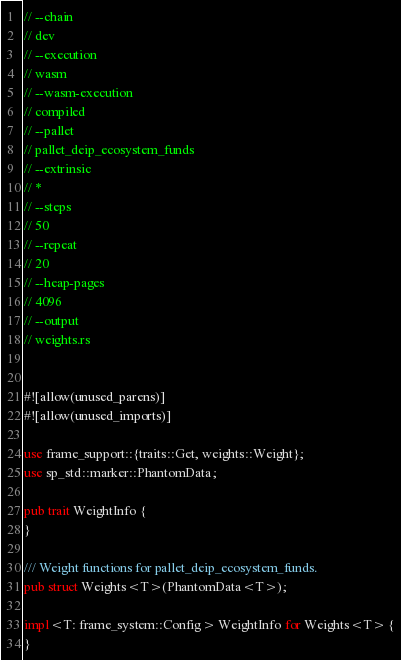<code> <loc_0><loc_0><loc_500><loc_500><_Rust_>// --chain
// dev
// --execution
// wasm
// --wasm-execution
// compiled
// --pallet
// pallet_deip_ecosystem_funds
// --extrinsic
// *
// --steps
// 50
// --repeat
// 20
// --heap-pages
// 4096
// --output
// weights.rs


#![allow(unused_parens)]
#![allow(unused_imports)]

use frame_support::{traits::Get, weights::Weight};
use sp_std::marker::PhantomData;

pub trait WeightInfo {
}

/// Weight functions for pallet_deip_ecosystem_funds.
pub struct Weights<T>(PhantomData<T>);

impl<T: frame_system::Config> WeightInfo for Weights<T> {
}
</code> 